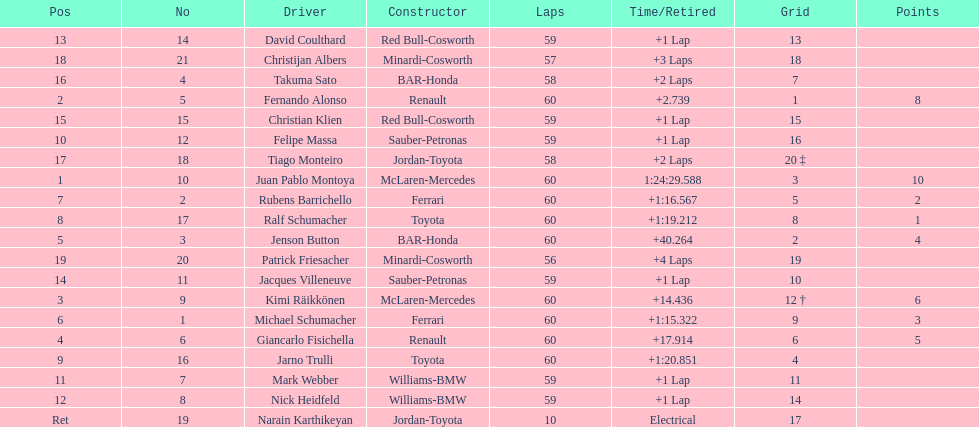After 8th position, how many points does a driver receive? 0. I'm looking to parse the entire table for insights. Could you assist me with that? {'header': ['Pos', 'No', 'Driver', 'Constructor', 'Laps', 'Time/Retired', 'Grid', 'Points'], 'rows': [['13', '14', 'David Coulthard', 'Red Bull-Cosworth', '59', '+1 Lap', '13', ''], ['18', '21', 'Christijan Albers', 'Minardi-Cosworth', '57', '+3 Laps', '18', ''], ['16', '4', 'Takuma Sato', 'BAR-Honda', '58', '+2 Laps', '7', ''], ['2', '5', 'Fernando Alonso', 'Renault', '60', '+2.739', '1', '8'], ['15', '15', 'Christian Klien', 'Red Bull-Cosworth', '59', '+1 Lap', '15', ''], ['10', '12', 'Felipe Massa', 'Sauber-Petronas', '59', '+1 Lap', '16', ''], ['17', '18', 'Tiago Monteiro', 'Jordan-Toyota', '58', '+2 Laps', '20 ‡', ''], ['1', '10', 'Juan Pablo Montoya', 'McLaren-Mercedes', '60', '1:24:29.588', '3', '10'], ['7', '2', 'Rubens Barrichello', 'Ferrari', '60', '+1:16.567', '5', '2'], ['8', '17', 'Ralf Schumacher', 'Toyota', '60', '+1:19.212', '8', '1'], ['5', '3', 'Jenson Button', 'BAR-Honda', '60', '+40.264', '2', '4'], ['19', '20', 'Patrick Friesacher', 'Minardi-Cosworth', '56', '+4 Laps', '19', ''], ['14', '11', 'Jacques Villeneuve', 'Sauber-Petronas', '59', '+1 Lap', '10', ''], ['3', '9', 'Kimi Räikkönen', 'McLaren-Mercedes', '60', '+14.436', '12 †', '6'], ['6', '1', 'Michael Schumacher', 'Ferrari', '60', '+1:15.322', '9', '3'], ['4', '6', 'Giancarlo Fisichella', 'Renault', '60', '+17.914', '6', '5'], ['9', '16', 'Jarno Trulli', 'Toyota', '60', '+1:20.851', '4', ''], ['11', '7', 'Mark Webber', 'Williams-BMW', '59', '+1 Lap', '11', ''], ['12', '8', 'Nick Heidfeld', 'Williams-BMW', '59', '+1 Lap', '14', ''], ['Ret', '19', 'Narain Karthikeyan', 'Jordan-Toyota', '10', 'Electrical', '17', '']]} 